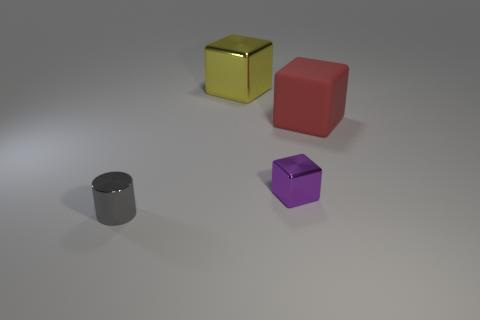There is a large cube behind the matte block; what number of blocks are on the right side of it?
Your answer should be very brief. 2. Is the number of rubber things right of the matte cube less than the number of purple objects?
Offer a terse response. Yes. The small metal thing behind the tiny object that is left of the metallic cube that is in front of the matte object is what shape?
Keep it short and to the point. Cube. Is the shape of the tiny gray thing the same as the red matte thing?
Keep it short and to the point. No. What number of other things are there of the same shape as the tiny gray object?
Your answer should be compact. 0. There is a object that is the same size as the shiny cylinder; what color is it?
Ensure brevity in your answer.  Purple. Are there an equal number of purple objects to the left of the big yellow block and tiny metallic objects?
Your answer should be very brief. No. What is the shape of the object that is both to the left of the large matte cube and behind the purple block?
Provide a short and direct response. Cube. Is the size of the yellow shiny cube the same as the cylinder?
Provide a short and direct response. No. Is there a red block made of the same material as the big yellow cube?
Your answer should be very brief. No. 